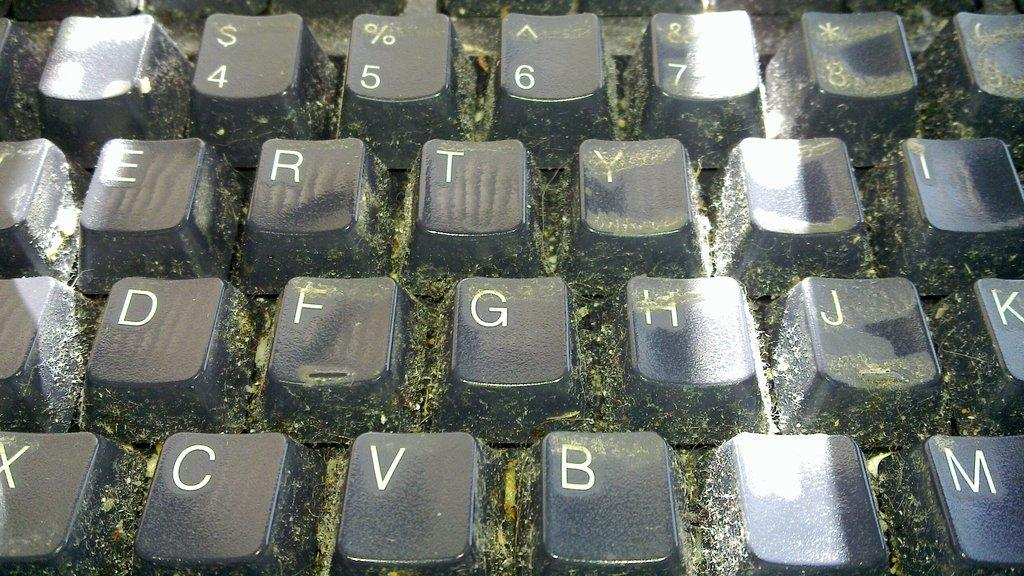<image>
Create a compact narrative representing the image presented. A dirty keyboard has the G key between the F and H keys. 